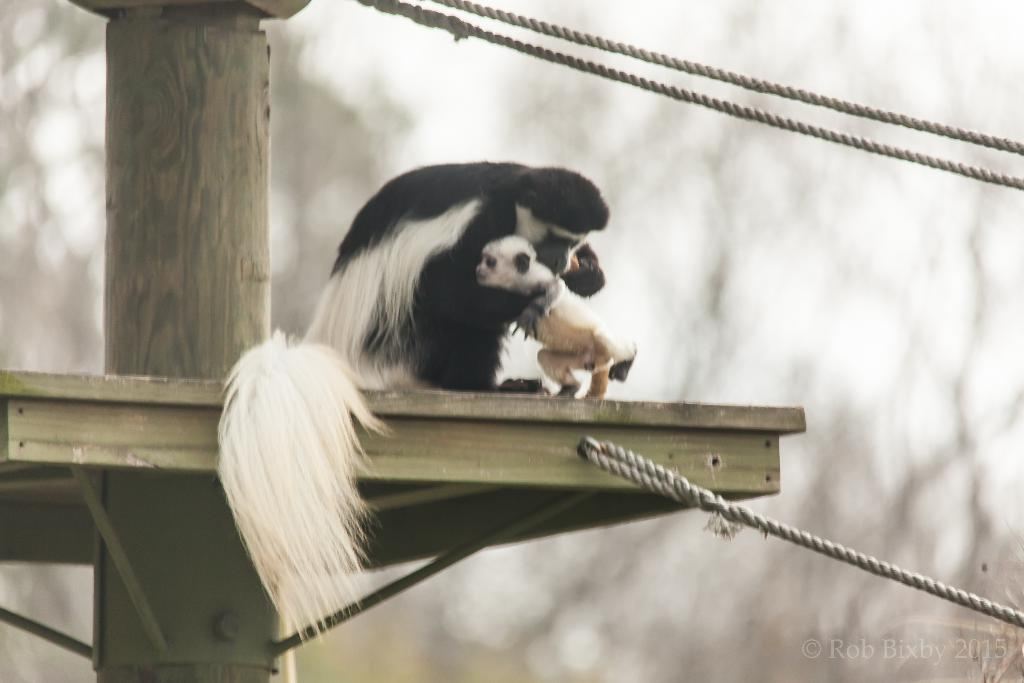What is located in the center of the image? There are animals, a wooden board, a wooden pole, and ropes in the center of the image. Can you describe the wooden board in the image? The wooden board is in the center of the image. What is the wooden pole used for in the image? The wooden pole is in the center of the image and may be used for support or as part of a structure. What can be seen in the background of the image? There are trees in the background of the image. What type of texture can be seen on the playground in the image? There is no playground present in the image; it features animals, a wooden board, a wooden pole, and ropes in the center, with trees in the background. How does the roll of fabric contribute to the scene in the image? There is no roll of fabric mentioned in the image; it features animals, a wooden board, a wooden pole, and ropes in the center, with trees in the background. 